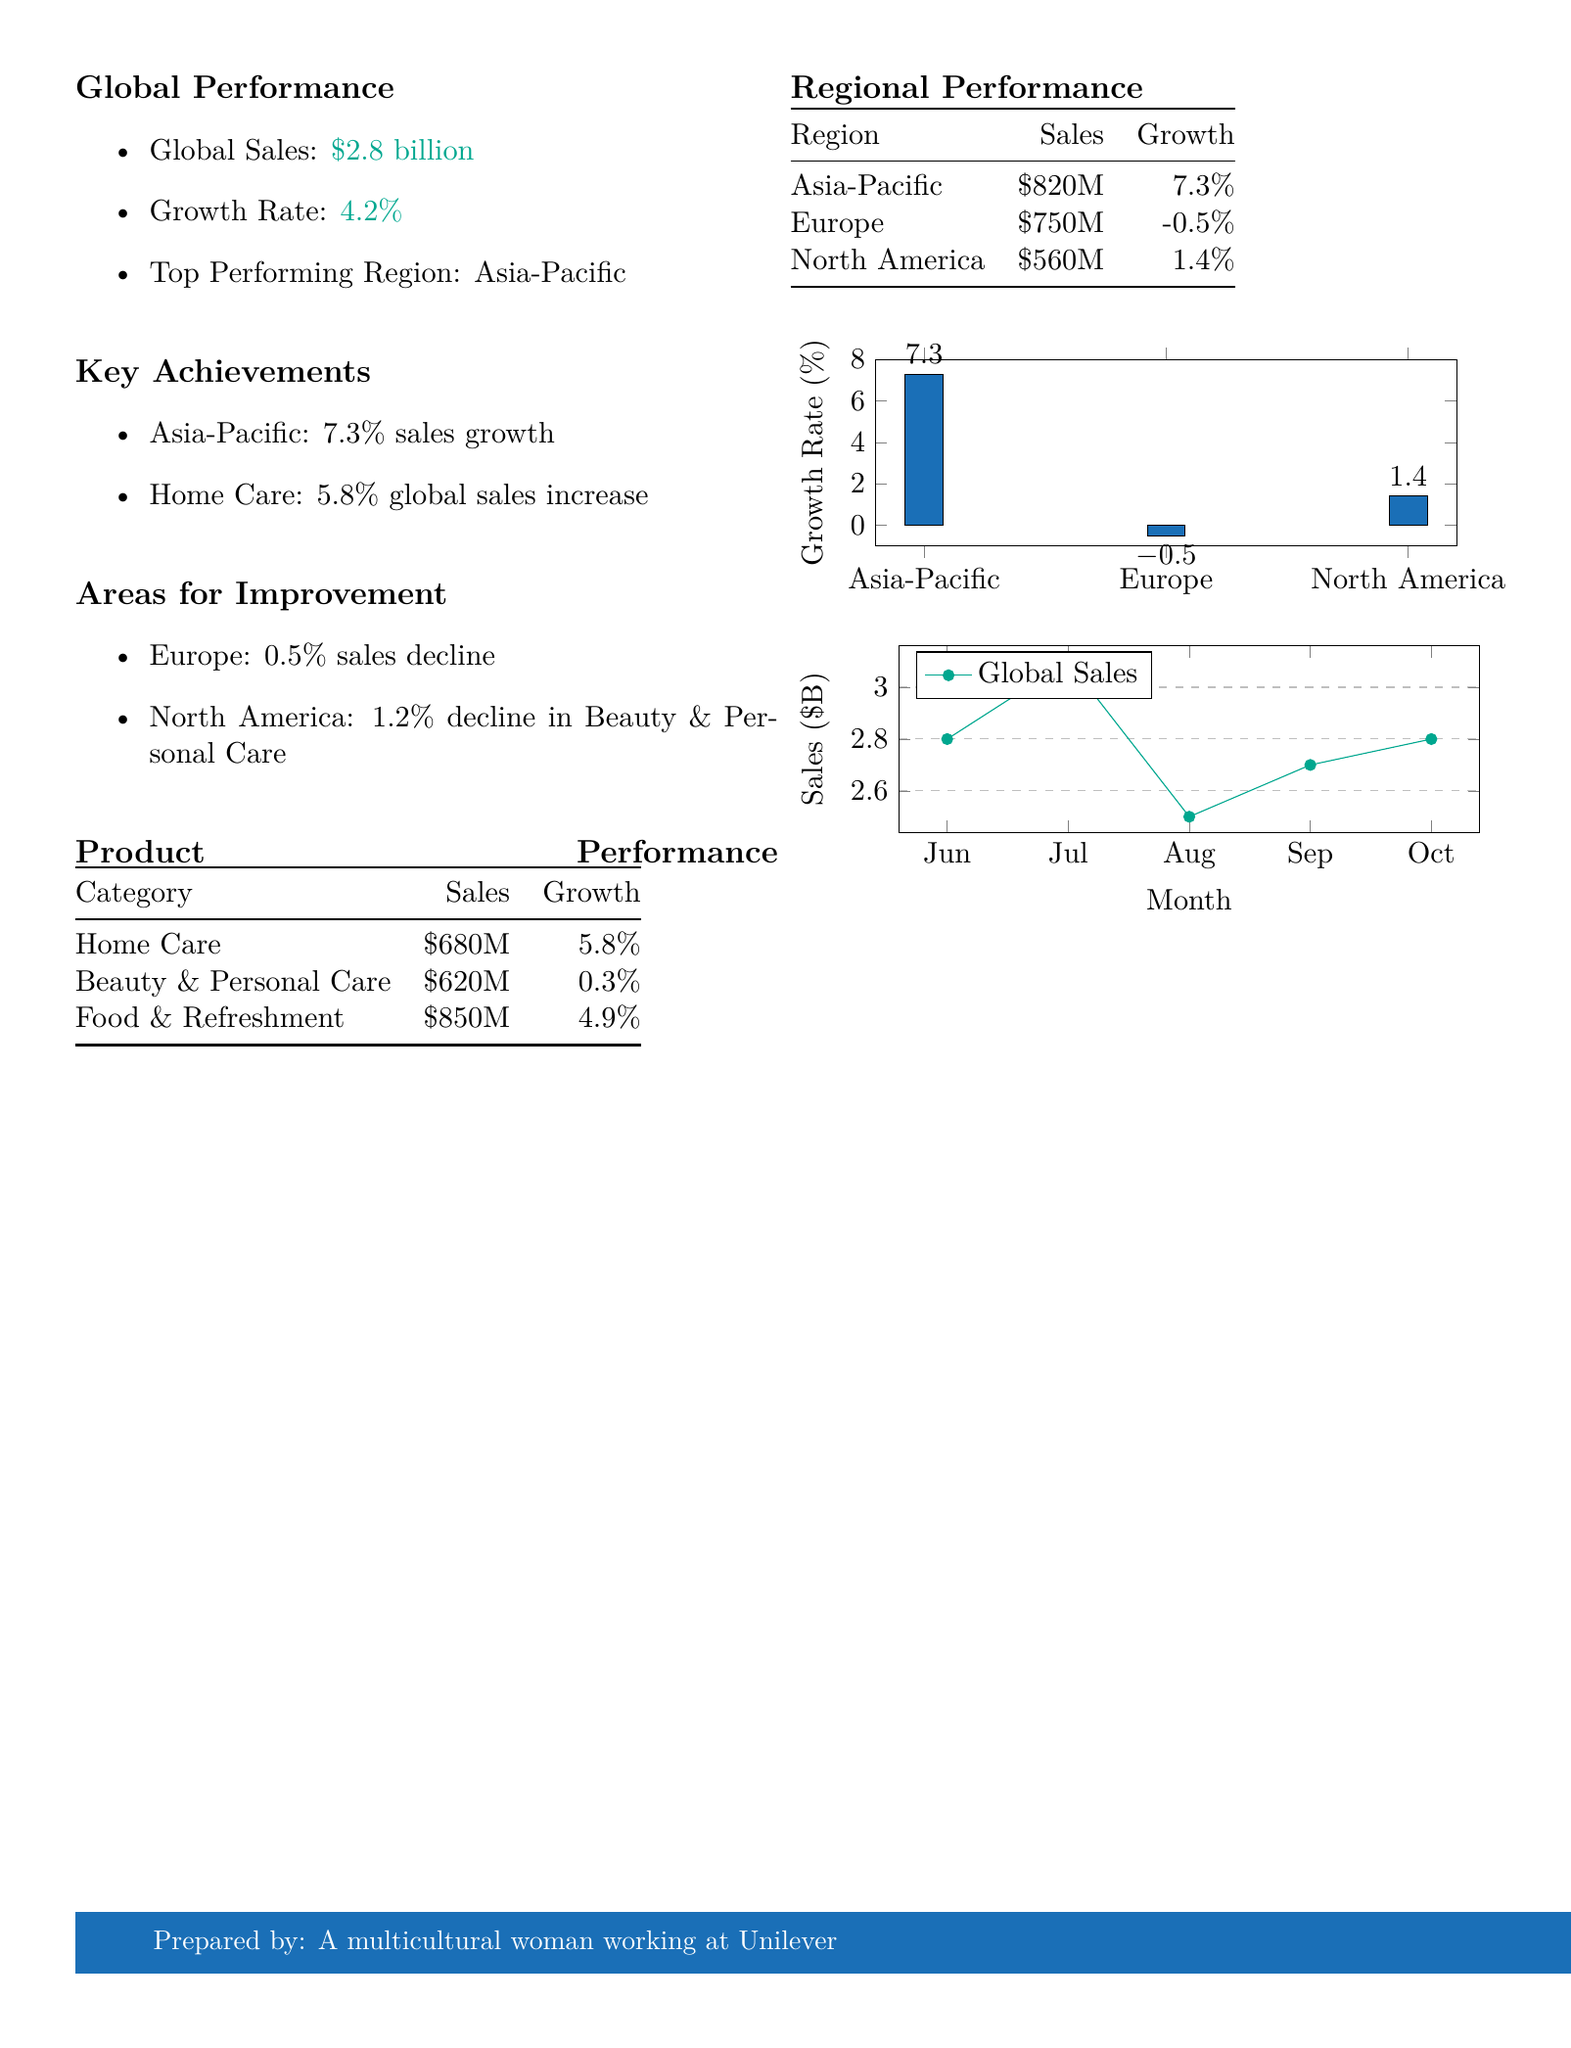what is the global sales figure? The global sales figure is highlighted in the Global Performance section of the document.
Answer: $2.8 billion what was the growth rate for the past month? The growth rate is mentioned immediately following the global sales figure in the Global Performance section.
Answer: 4.2% which region has the highest sales growth? The information is found in the Key Achievements section, which lists regions with sales growth.
Answer: Asia-Pacific what was the sales amount for Beauty & Personal Care? The sales amount for Beauty & Personal Care is displayed in the Product Performance table.
Answer: $620 million which product category had the lowest growth rate? This can be derived from the Product Performance table where growth rates are listed.
Answer: Beauty & Personal Care what is the sales figure for North America? The sales figure for North America is found in the Regional Performance table.
Answer: $560 million which region experienced a sales decline? The Areas for Improvement section lists regions with sales declines, making it easy to identify the region.
Answer: Europe what was the sales growth for Home Care? The sales growth for Home Care is explicitly provided in the Product Performance section.
Answer: 5.8% how many regions are listed in the Regional Performance table? The count of regions can be determined by checking the number of entries in the Regional Performance table.
Answer: 3 